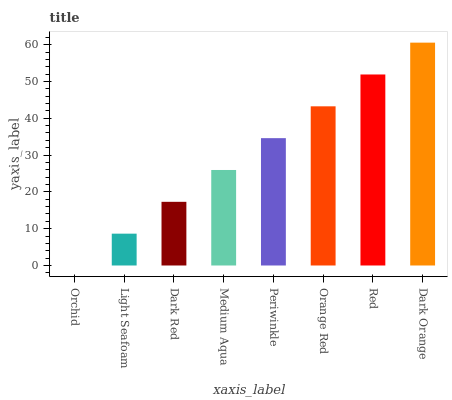Is Orchid the minimum?
Answer yes or no. Yes. Is Dark Orange the maximum?
Answer yes or no. Yes. Is Light Seafoam the minimum?
Answer yes or no. No. Is Light Seafoam the maximum?
Answer yes or no. No. Is Light Seafoam greater than Orchid?
Answer yes or no. Yes. Is Orchid less than Light Seafoam?
Answer yes or no. Yes. Is Orchid greater than Light Seafoam?
Answer yes or no. No. Is Light Seafoam less than Orchid?
Answer yes or no. No. Is Periwinkle the high median?
Answer yes or no. Yes. Is Medium Aqua the low median?
Answer yes or no. Yes. Is Medium Aqua the high median?
Answer yes or no. No. Is Red the low median?
Answer yes or no. No. 